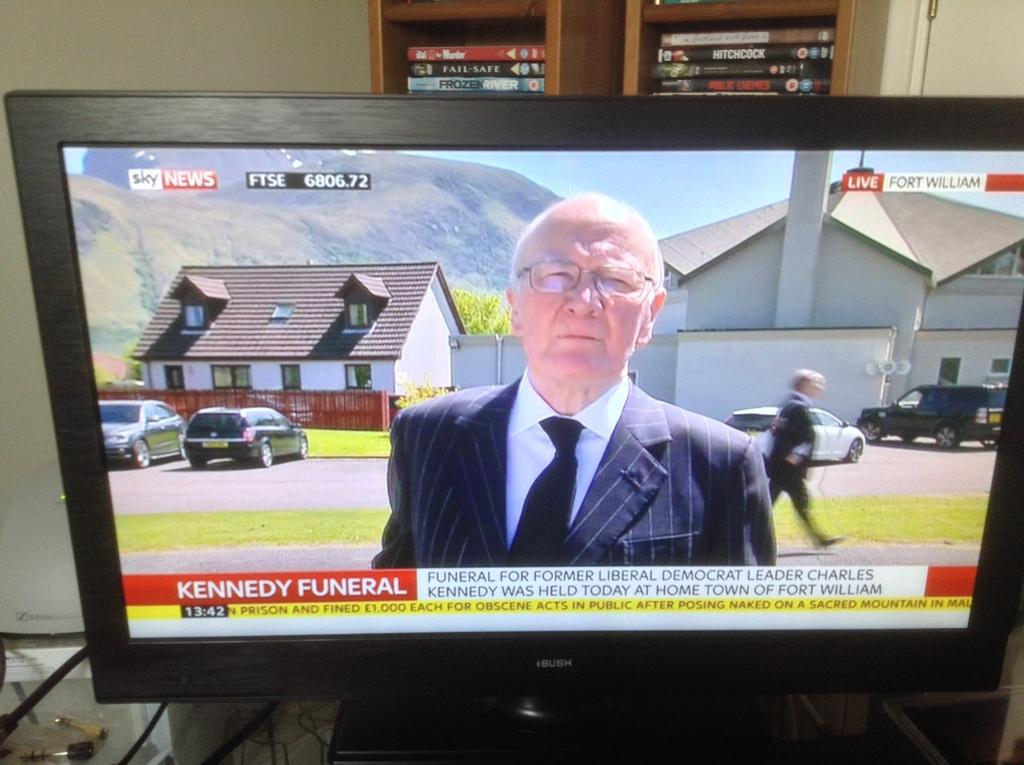Who's funeral is being broadcasting on tv?
Provide a short and direct response. Kennedy. What channel is this?
Your response must be concise. Sky news. 